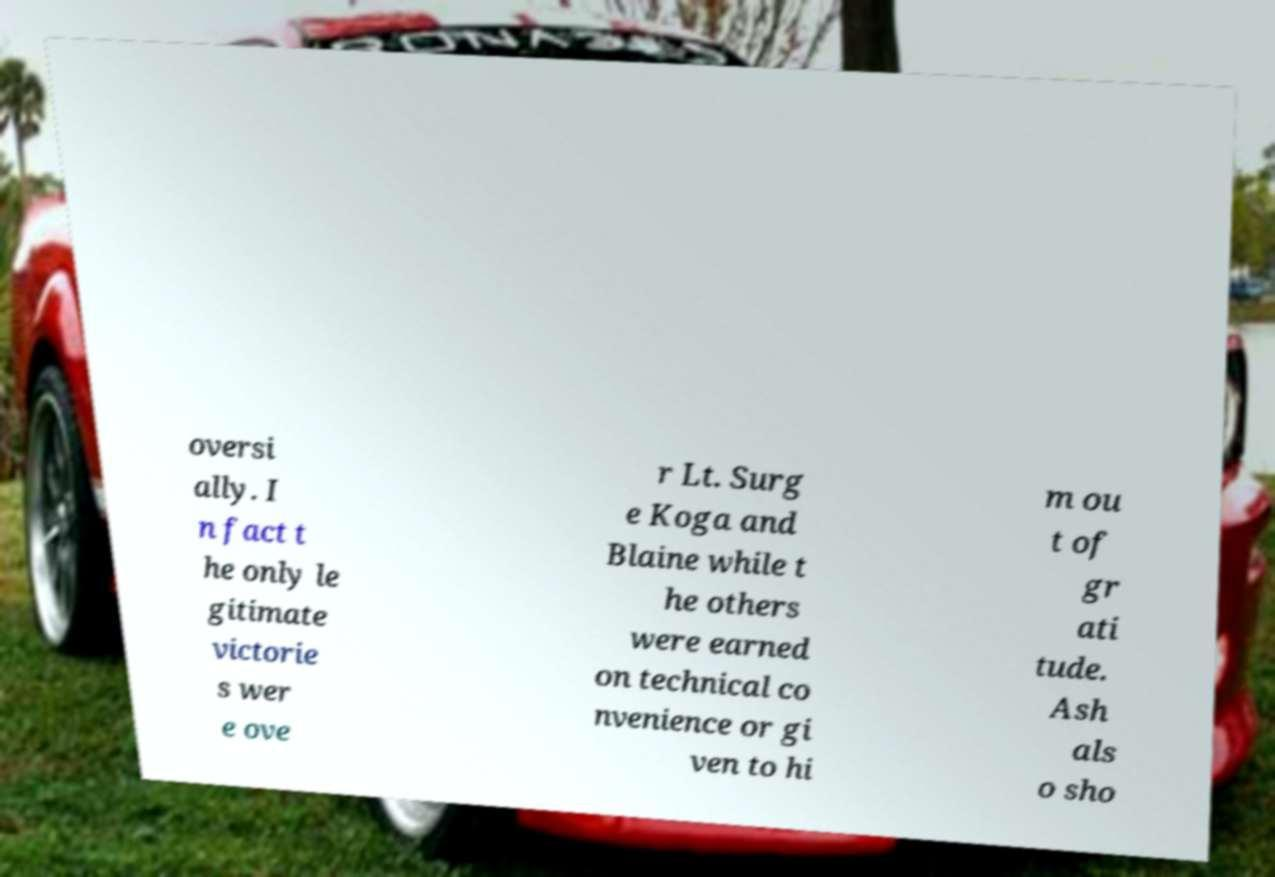Can you accurately transcribe the text from the provided image for me? oversi ally. I n fact t he only le gitimate victorie s wer e ove r Lt. Surg e Koga and Blaine while t he others were earned on technical co nvenience or gi ven to hi m ou t of gr ati tude. Ash als o sho 